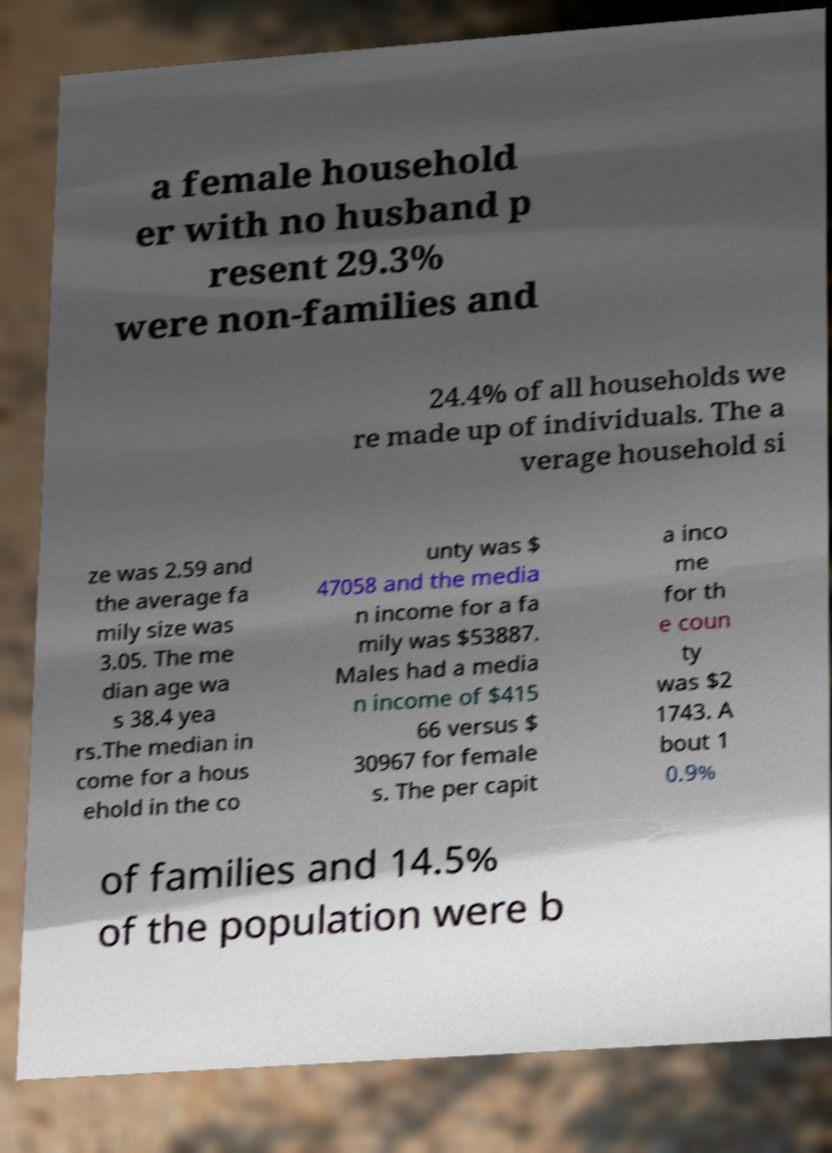I need the written content from this picture converted into text. Can you do that? a female household er with no husband p resent 29.3% were non-families and 24.4% of all households we re made up of individuals. The a verage household si ze was 2.59 and the average fa mily size was 3.05. The me dian age wa s 38.4 yea rs.The median in come for a hous ehold in the co unty was $ 47058 and the media n income for a fa mily was $53887. Males had a media n income of $415 66 versus $ 30967 for female s. The per capit a inco me for th e coun ty was $2 1743. A bout 1 0.9% of families and 14.5% of the population were b 